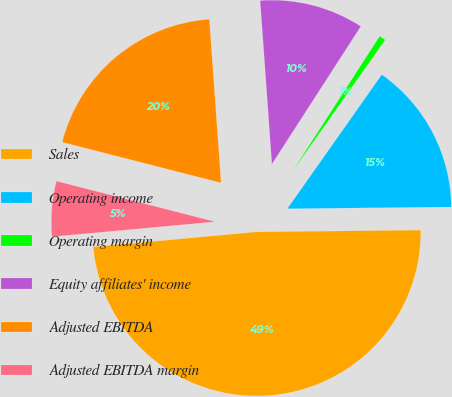Convert chart. <chart><loc_0><loc_0><loc_500><loc_500><pie_chart><fcel>Sales<fcel>Operating income<fcel>Operating margin<fcel>Equity affiliates' income<fcel>Adjusted EBITDA<fcel>Adjusted EBITDA margin<nl><fcel>48.71%<fcel>15.06%<fcel>0.65%<fcel>10.26%<fcel>19.87%<fcel>5.45%<nl></chart> 